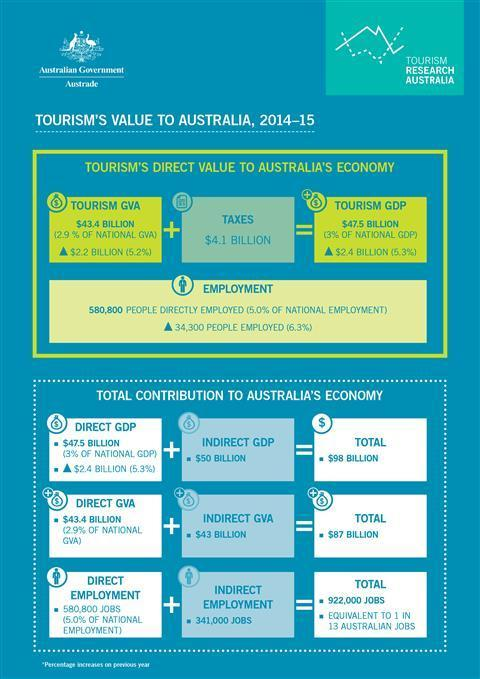How much is the amount of Tourism GDP
Answer the question with a short phrase. $47.5 Billion What is the total of Tourism GVA and Taxes? $47.5 Billion How many Indirect Jobs are available in Australia? 341,000 What is the total of Direct GDP and Indirect GDP? $98 Billion How many direct jobs are available under Australian Government? 580,800 jobs What percent of the National GDP is not Direct GDP? 97% What is the value of Tourism GVA 43.4 Billion What is the total of Direct GVA and Indirect GVA ? $87 Billion 